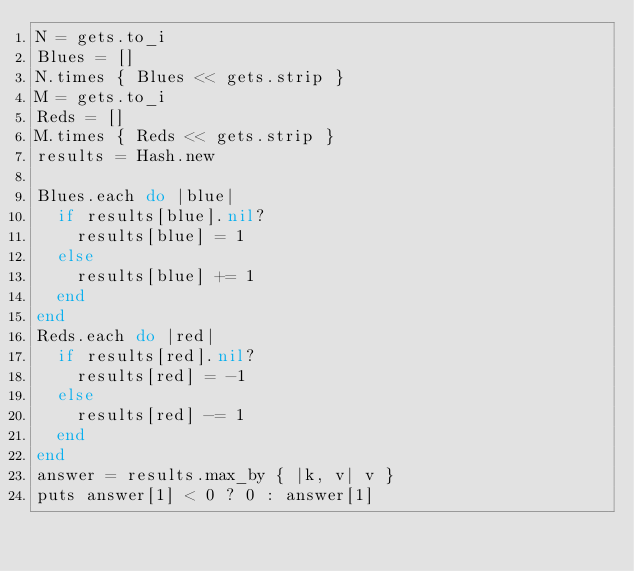Convert code to text. <code><loc_0><loc_0><loc_500><loc_500><_Ruby_>N = gets.to_i
Blues = []
N.times { Blues << gets.strip }
M = gets.to_i
Reds = []
M.times { Reds << gets.strip }
results = Hash.new

Blues.each do |blue|
  if results[blue].nil?
    results[blue] = 1
  else
    results[blue] += 1
  end
end
Reds.each do |red|
  if results[red].nil?
    results[red] = -1
  else
    results[red] -= 1
  end
end
answer = results.max_by { |k, v| v }
puts answer[1] < 0 ? 0 : answer[1]</code> 